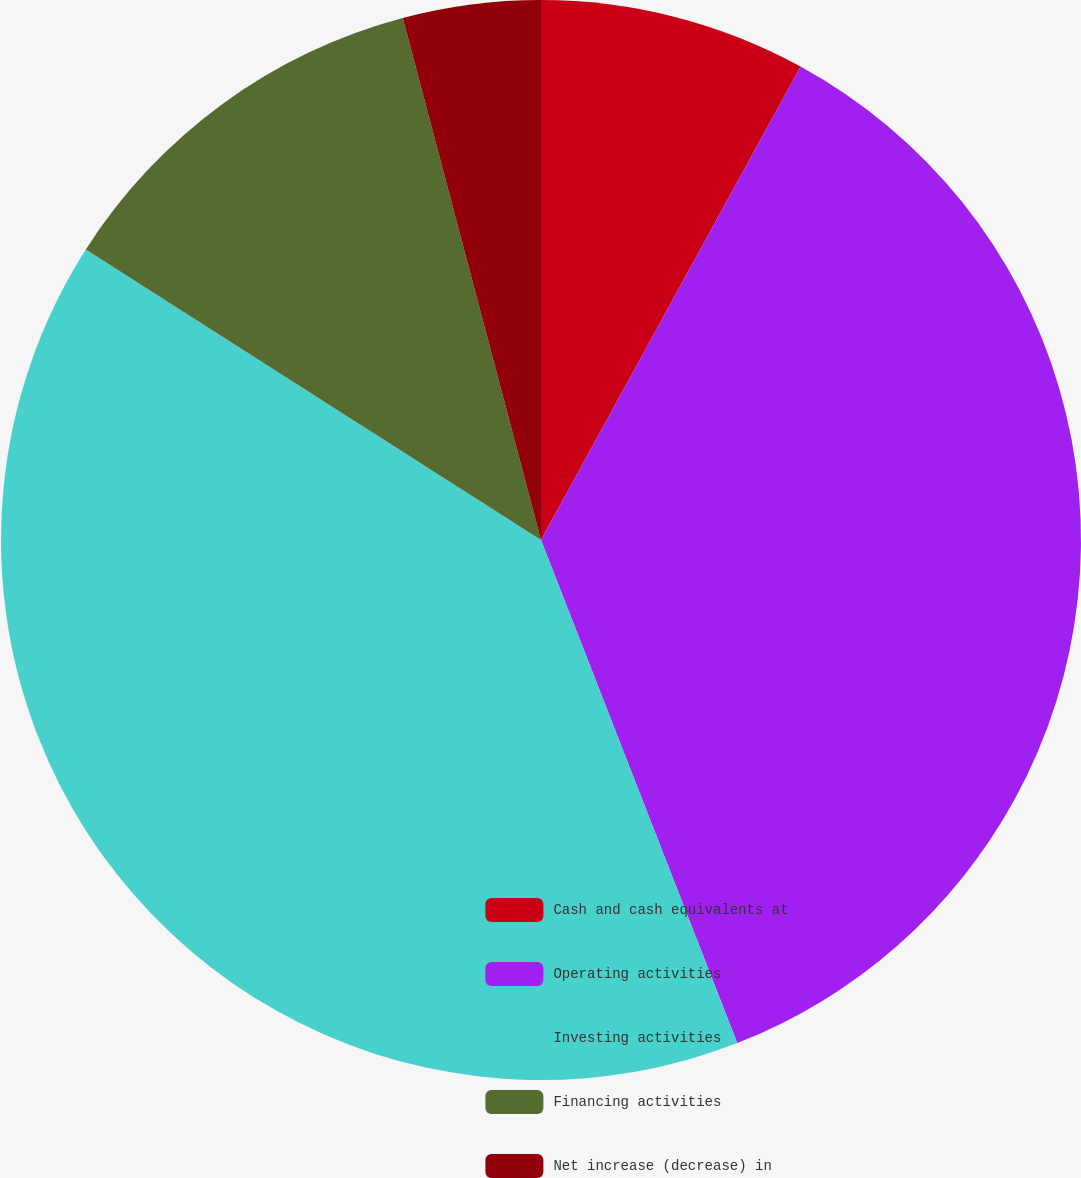Convert chart to OTSL. <chart><loc_0><loc_0><loc_500><loc_500><pie_chart><fcel>Cash and cash equivalents at<fcel>Operating activities<fcel>Investing activities<fcel>Financing activities<fcel>Net increase (decrease) in<nl><fcel>7.98%<fcel>36.1%<fcel>39.96%<fcel>11.84%<fcel>4.12%<nl></chart> 